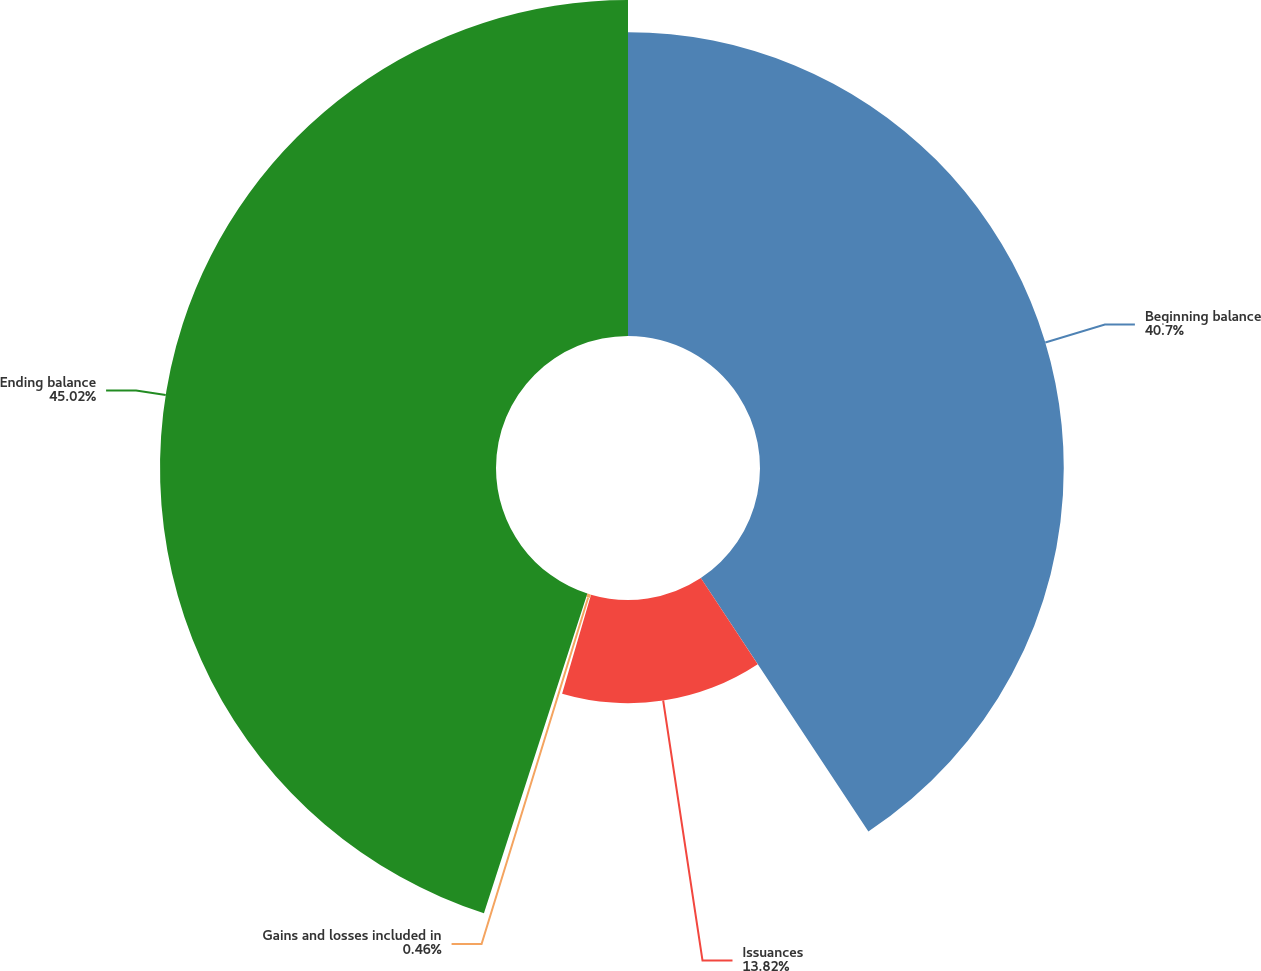<chart> <loc_0><loc_0><loc_500><loc_500><pie_chart><fcel>Beginning balance<fcel>Issuances<fcel>Gains and losses included in<fcel>Ending balance<nl><fcel>40.7%<fcel>13.82%<fcel>0.46%<fcel>45.02%<nl></chart> 